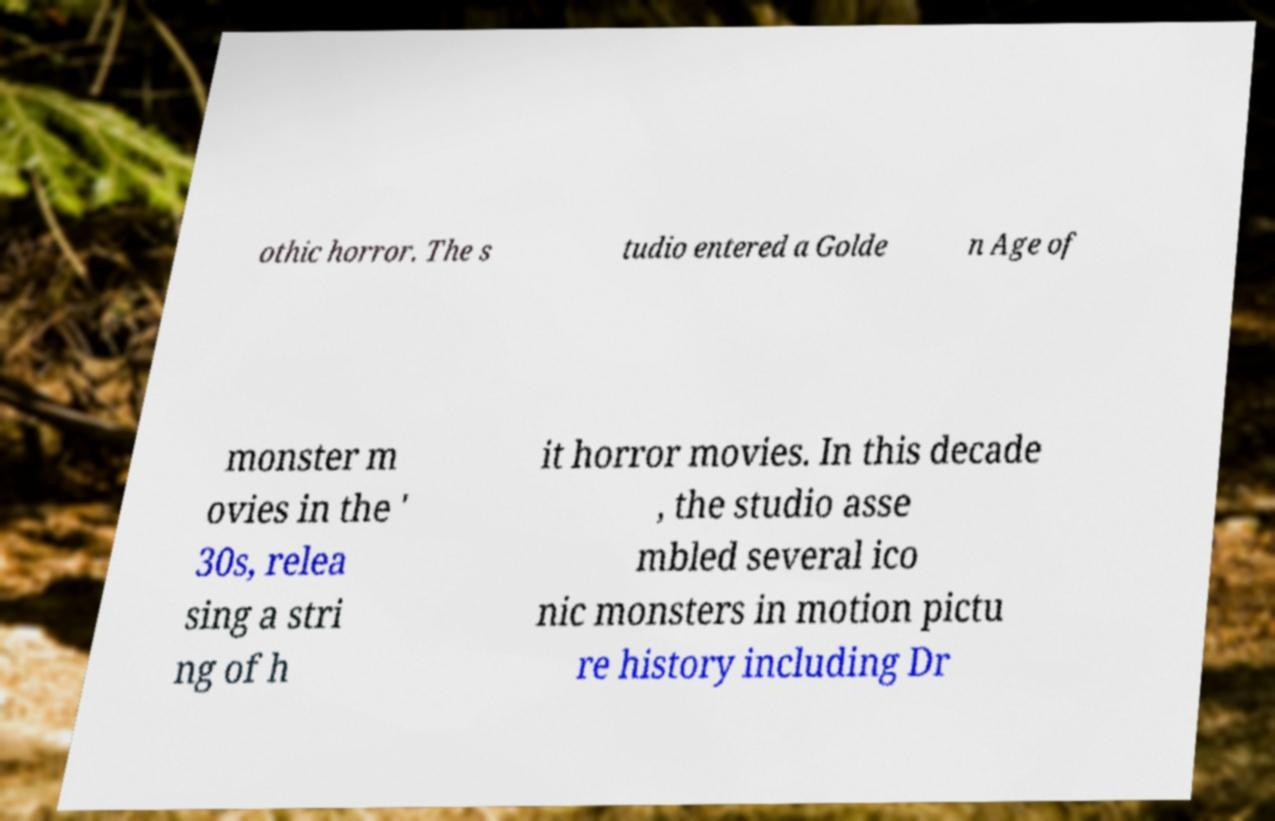There's text embedded in this image that I need extracted. Can you transcribe it verbatim? othic horror. The s tudio entered a Golde n Age of monster m ovies in the ' 30s, relea sing a stri ng of h it horror movies. In this decade , the studio asse mbled several ico nic monsters in motion pictu re history including Dr 